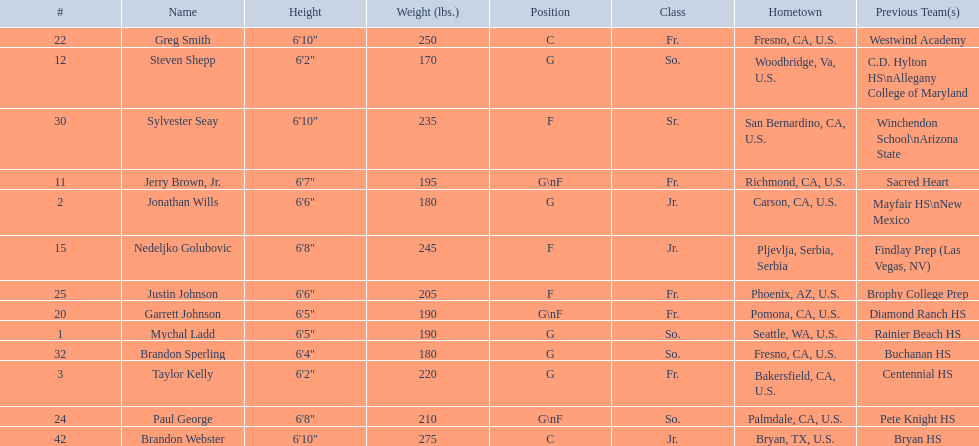Who are all the players in the 2009-10 fresno state bulldogs men's basketball team? Mychal Ladd, Jonathan Wills, Taylor Kelly, Jerry Brown, Jr., Steven Shepp, Nedeljko Golubovic, Garrett Johnson, Greg Smith, Paul George, Justin Johnson, Sylvester Seay, Brandon Sperling, Brandon Webster. Of these players, who are the ones who play forward? Jerry Brown, Jr., Nedeljko Golubovic, Garrett Johnson, Paul George, Justin Johnson, Sylvester Seay. Of these players, which ones only play forward and no other position? Nedeljko Golubovic, Justin Johnson, Sylvester Seay. Of these players, who is the shortest? Justin Johnson. 